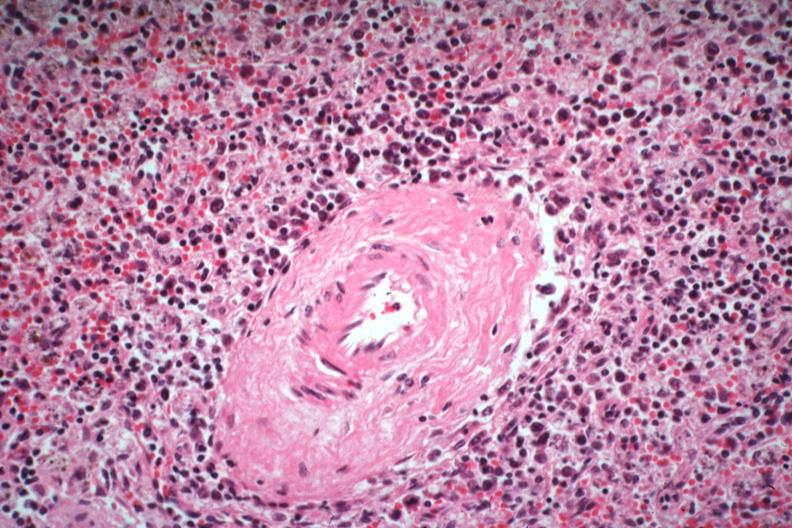what is atypical appearing immunoblastic cells near splenic arteriole man died?
Answer the question using a single word or phrase. Of what was thought to be viral pneumonia probably influenza 